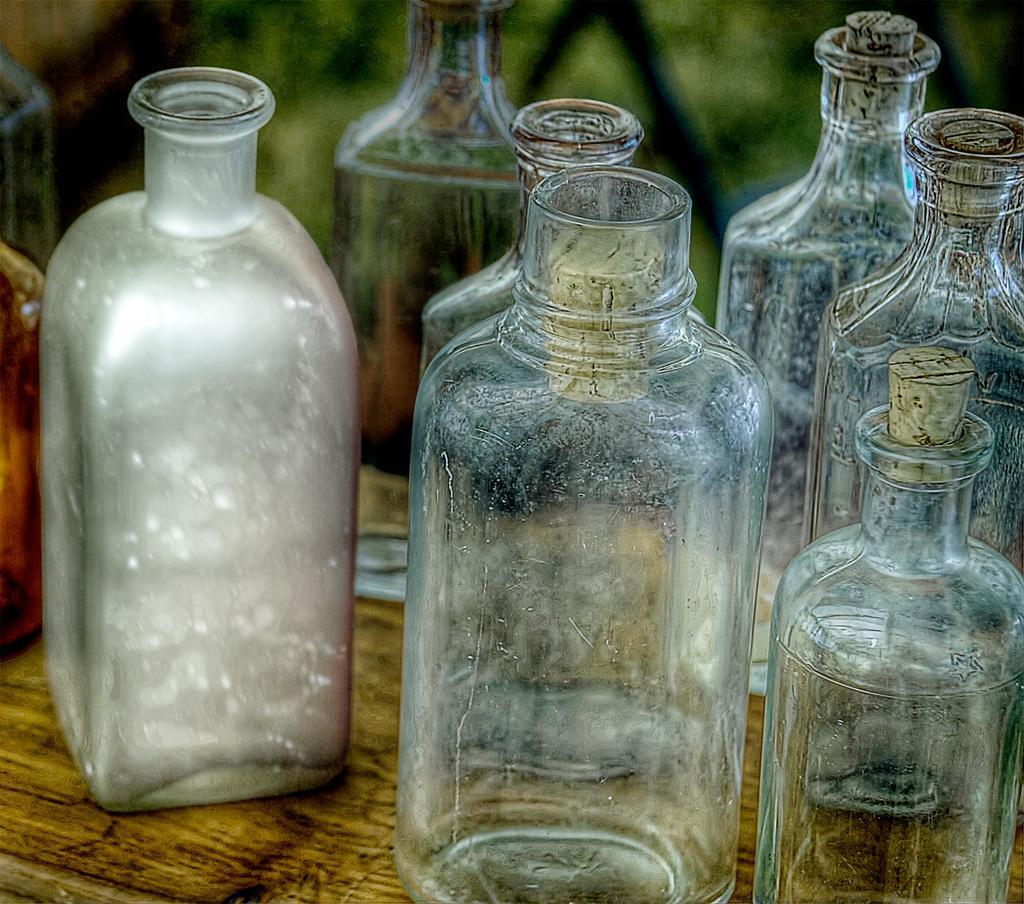How would you summarize this image in a sentence or two? In the image there are few bottles which are placed on table. 